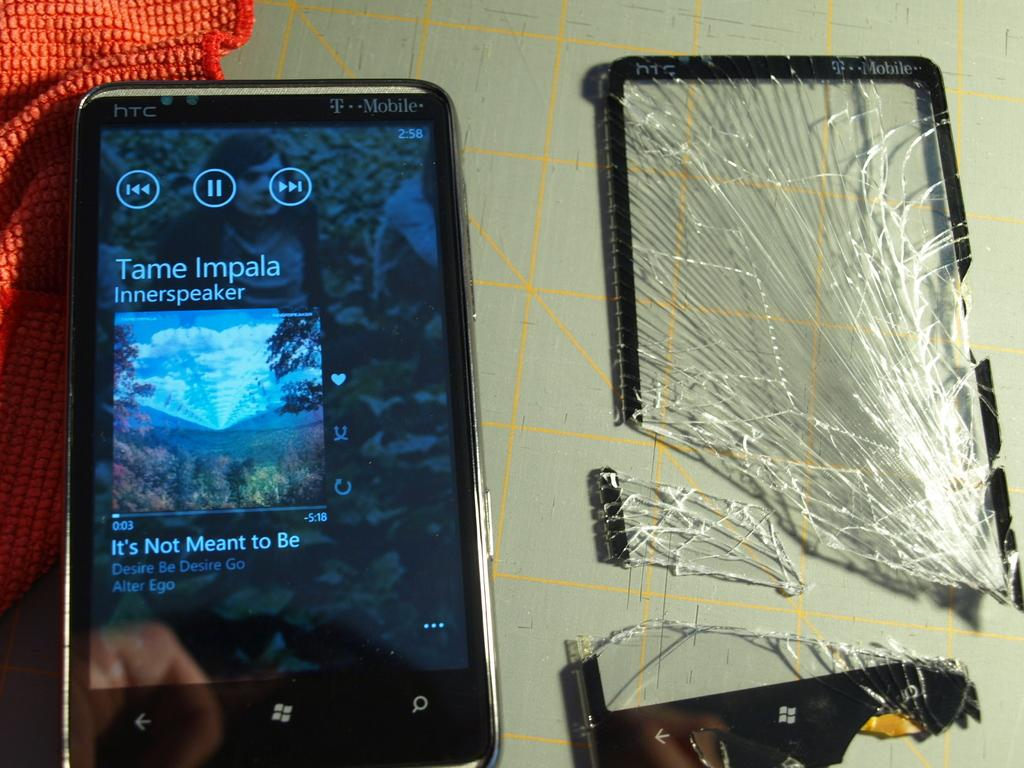Provide a one-sentence caption for the provided image. A phone displaying the song it's not meant to be. 